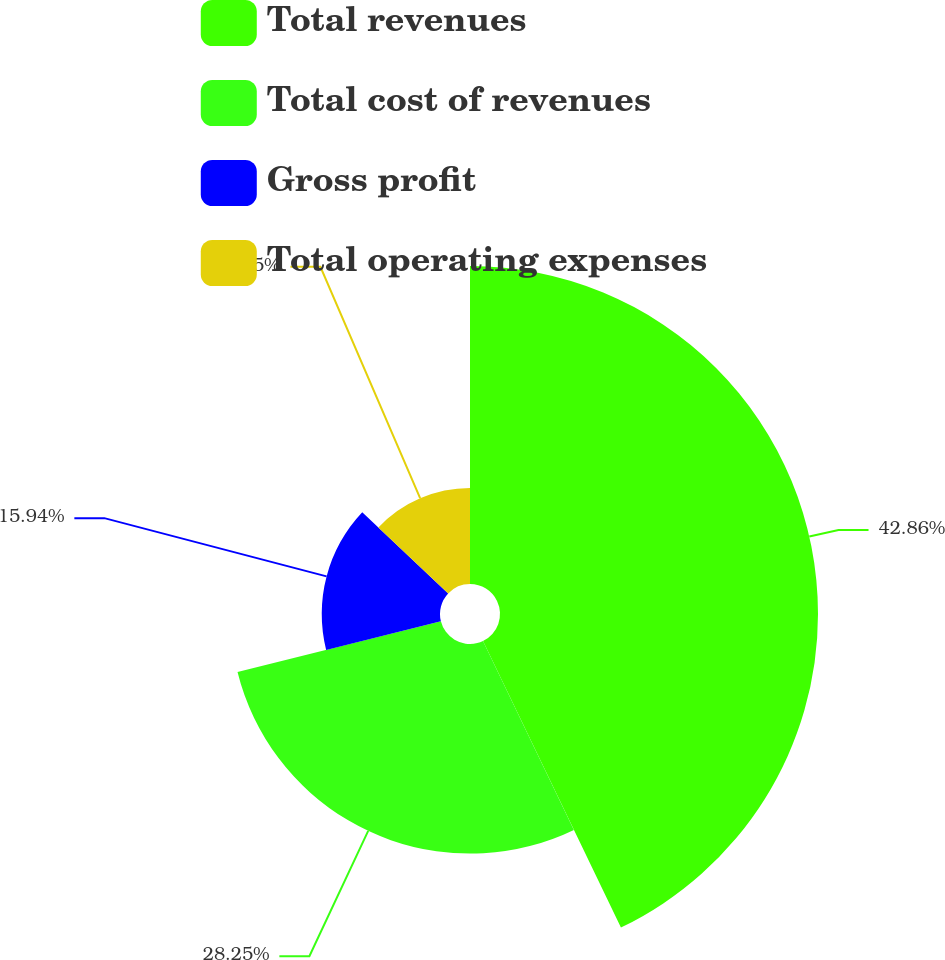Convert chart to OTSL. <chart><loc_0><loc_0><loc_500><loc_500><pie_chart><fcel>Total revenues<fcel>Total cost of revenues<fcel>Gross profit<fcel>Total operating expenses<nl><fcel>42.86%<fcel>28.25%<fcel>15.94%<fcel>12.95%<nl></chart> 